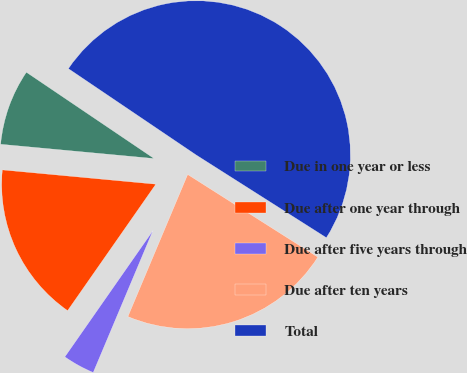<chart> <loc_0><loc_0><loc_500><loc_500><pie_chart><fcel>Due in one year or less<fcel>Due after one year through<fcel>Due after five years through<fcel>Due after ten years<fcel>Total<nl><fcel>7.98%<fcel>16.78%<fcel>3.36%<fcel>22.33%<fcel>49.55%<nl></chart> 